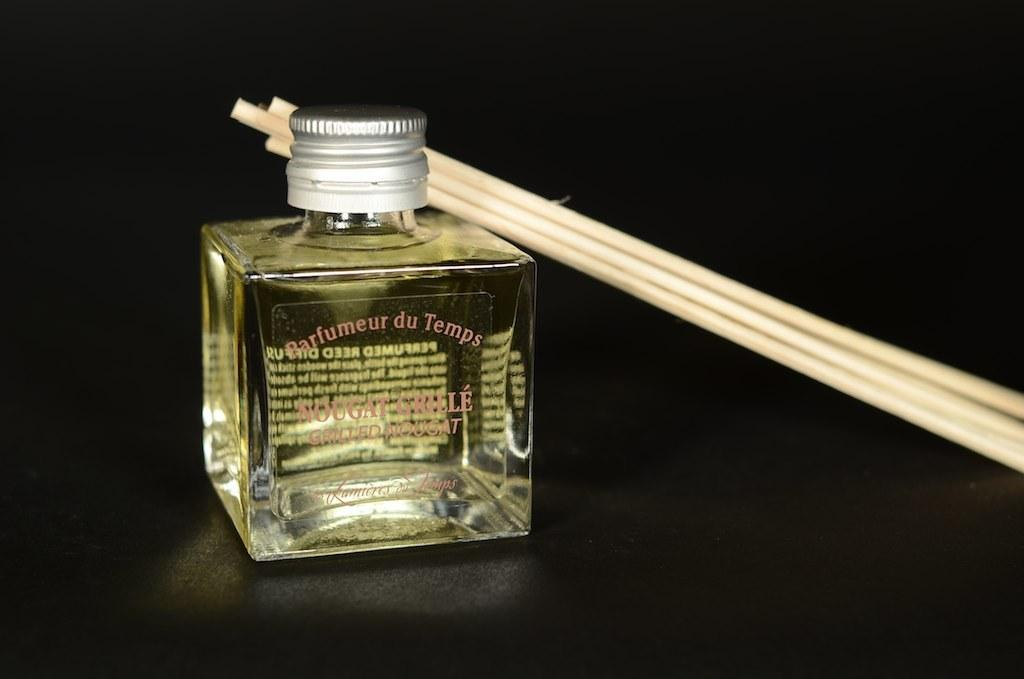<image>
Relay a brief, clear account of the picture shown. The diffused perfume is of a grilled nougat scent. 